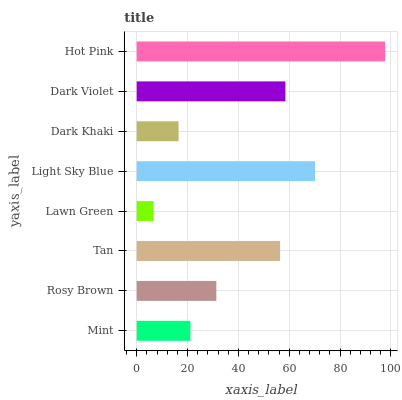Is Lawn Green the minimum?
Answer yes or no. Yes. Is Hot Pink the maximum?
Answer yes or no. Yes. Is Rosy Brown the minimum?
Answer yes or no. No. Is Rosy Brown the maximum?
Answer yes or no. No. Is Rosy Brown greater than Mint?
Answer yes or no. Yes. Is Mint less than Rosy Brown?
Answer yes or no. Yes. Is Mint greater than Rosy Brown?
Answer yes or no. No. Is Rosy Brown less than Mint?
Answer yes or no. No. Is Tan the high median?
Answer yes or no. Yes. Is Rosy Brown the low median?
Answer yes or no. Yes. Is Dark Violet the high median?
Answer yes or no. No. Is Hot Pink the low median?
Answer yes or no. No. 